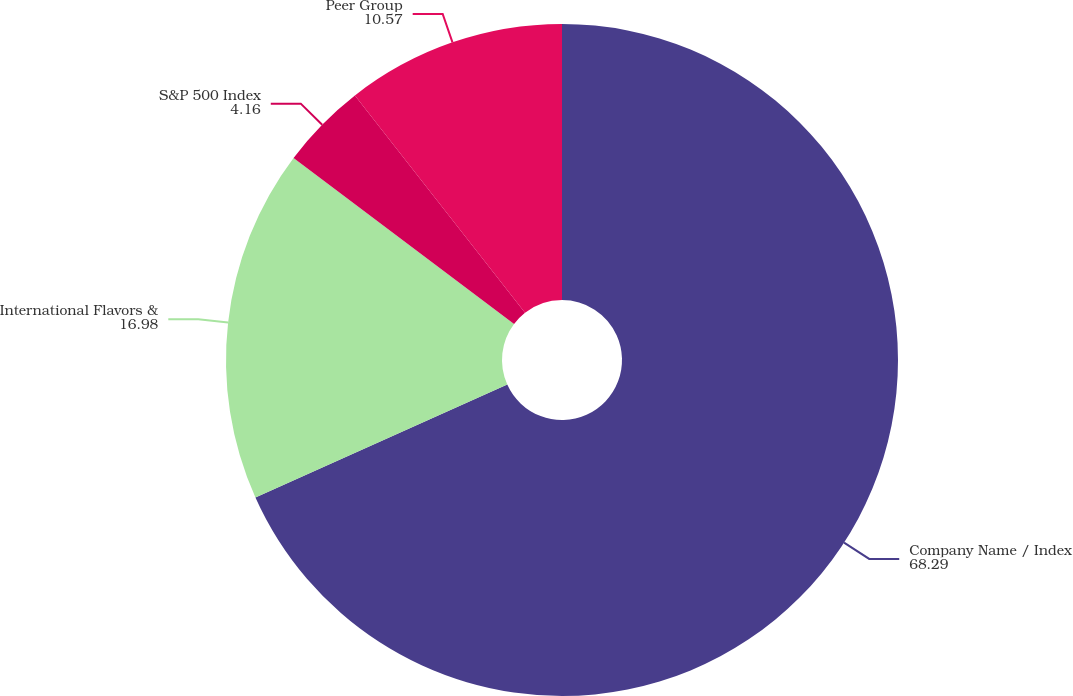<chart> <loc_0><loc_0><loc_500><loc_500><pie_chart><fcel>Company Name / Index<fcel>International Flavors &<fcel>S&P 500 Index<fcel>Peer Group<nl><fcel>68.29%<fcel>16.98%<fcel>4.16%<fcel>10.57%<nl></chart> 